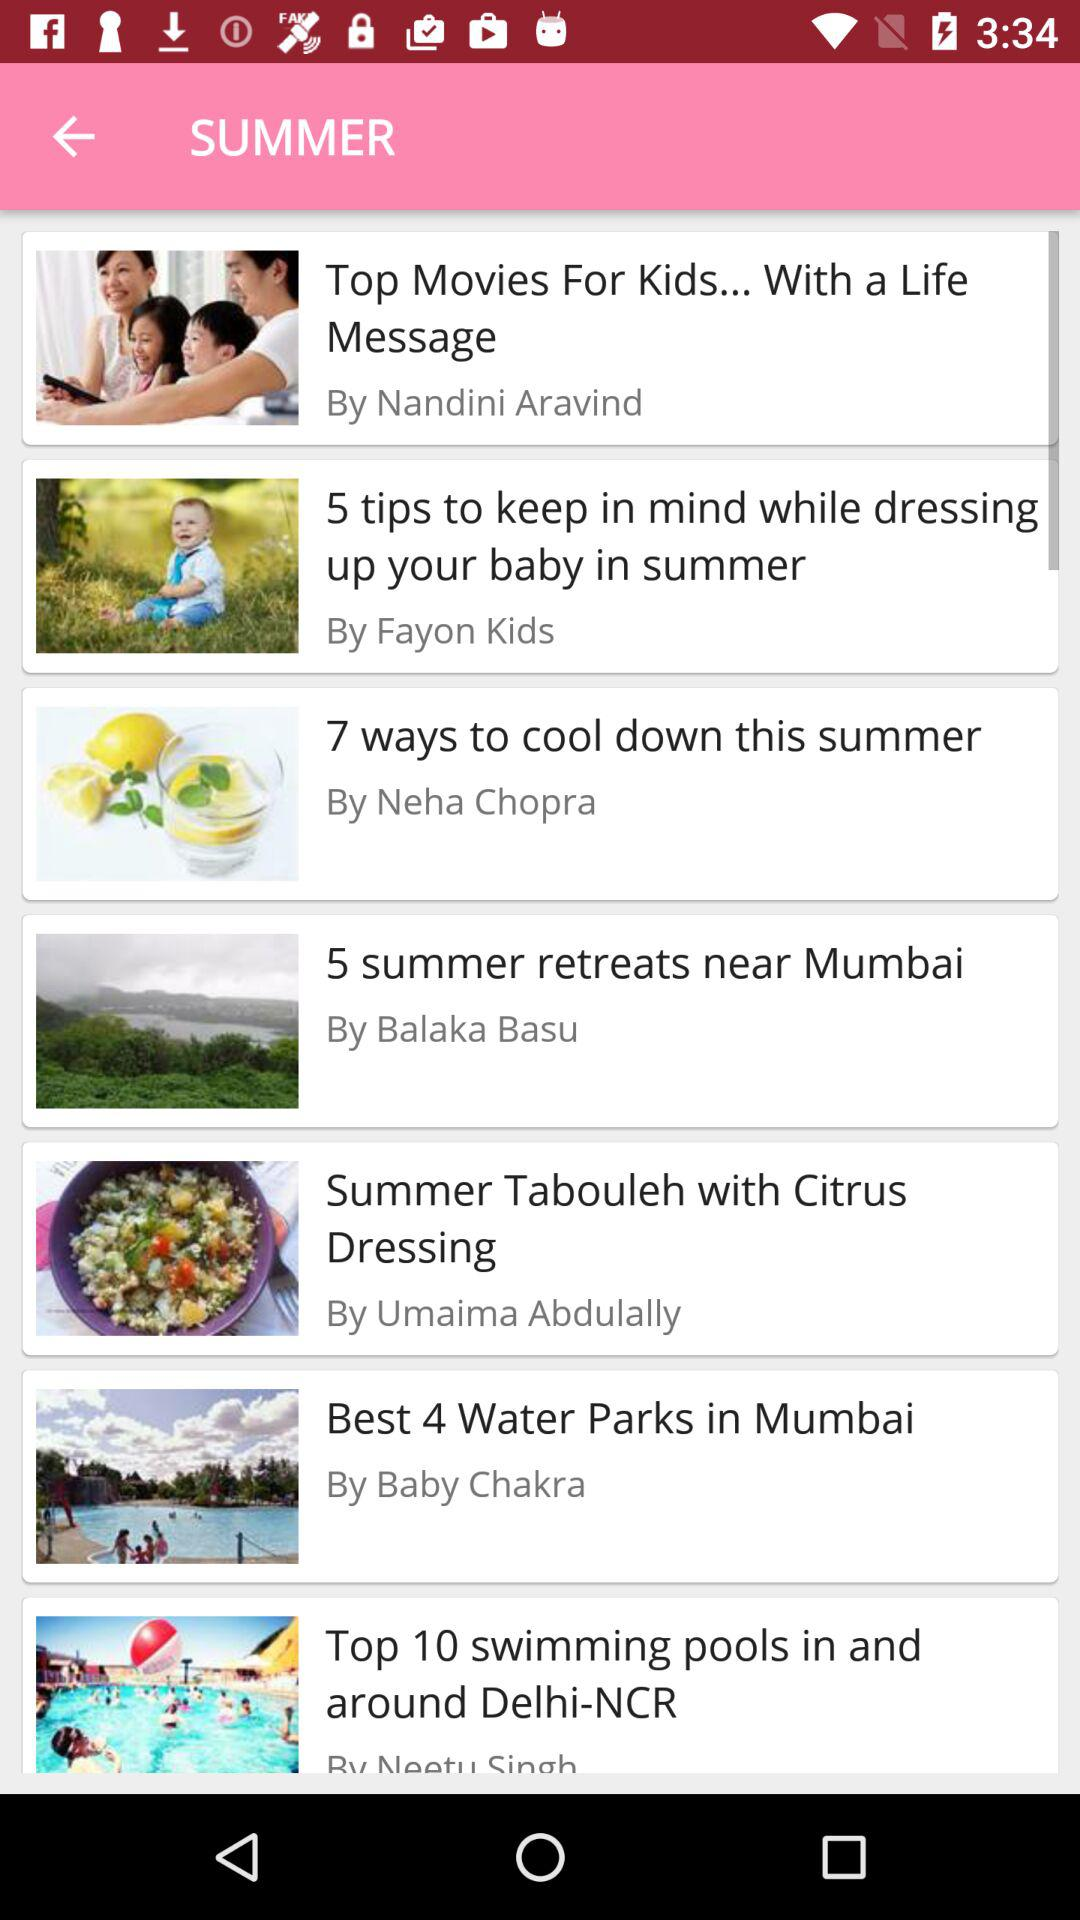What article is written by Nandini Aravind? The article written by Nandini Aravind is "Top Movies For Kids... With a Life Message". 